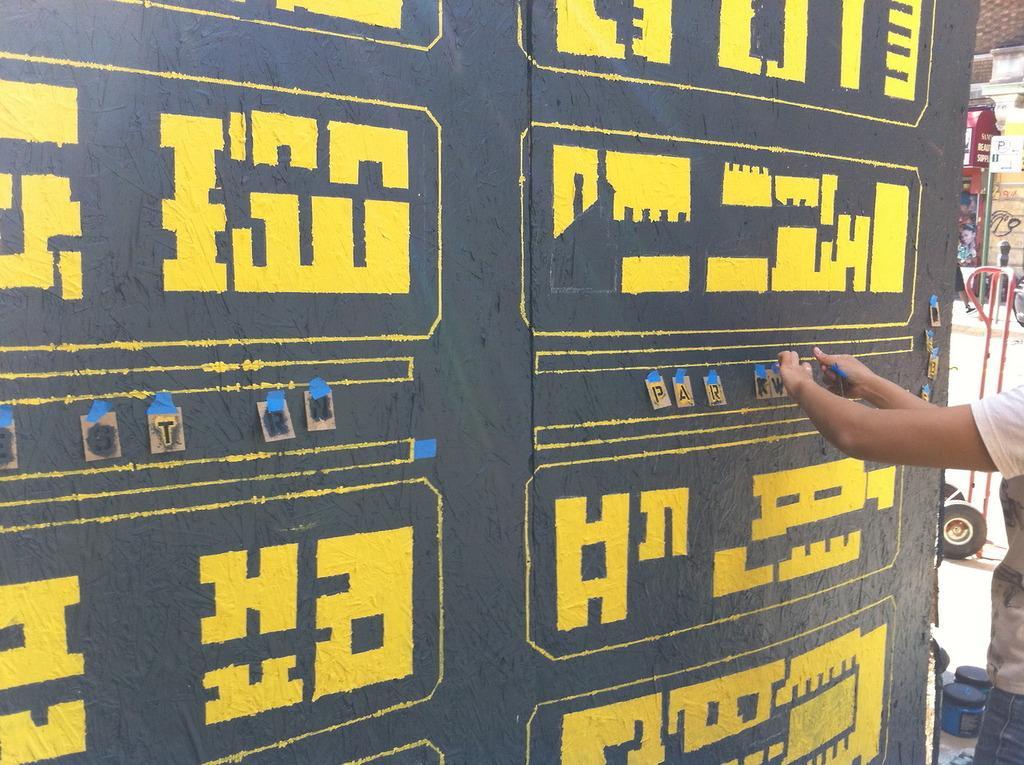In one or two sentences, can you explain what this image depicts? In the center of the image there is a wall. On the right side of the image there is a road and person standing on the road. 